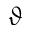Convert formula to latex. <formula><loc_0><loc_0><loc_500><loc_500>\vartheta</formula> 